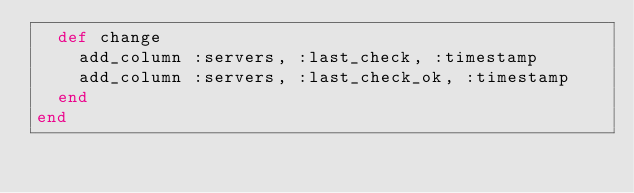<code> <loc_0><loc_0><loc_500><loc_500><_Ruby_>  def change
    add_column :servers, :last_check, :timestamp
    add_column :servers, :last_check_ok, :timestamp
  end
end
</code> 